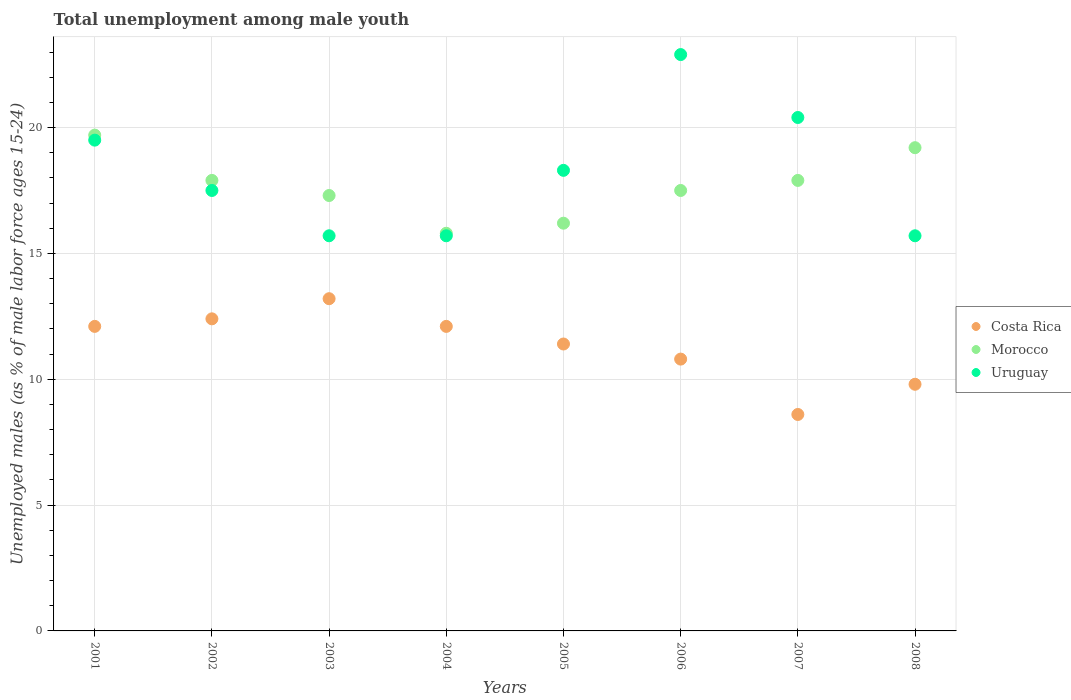How many different coloured dotlines are there?
Your answer should be very brief. 3. Is the number of dotlines equal to the number of legend labels?
Your response must be concise. Yes. What is the percentage of unemployed males in in Costa Rica in 2004?
Ensure brevity in your answer.  12.1. Across all years, what is the maximum percentage of unemployed males in in Costa Rica?
Provide a succinct answer. 13.2. Across all years, what is the minimum percentage of unemployed males in in Costa Rica?
Make the answer very short. 8.6. What is the total percentage of unemployed males in in Uruguay in the graph?
Keep it short and to the point. 145.7. What is the difference between the percentage of unemployed males in in Costa Rica in 2001 and that in 2008?
Give a very brief answer. 2.3. What is the difference between the percentage of unemployed males in in Costa Rica in 2006 and the percentage of unemployed males in in Morocco in 2002?
Keep it short and to the point. -7.1. What is the average percentage of unemployed males in in Morocco per year?
Offer a terse response. 17.69. In the year 2006, what is the difference between the percentage of unemployed males in in Costa Rica and percentage of unemployed males in in Uruguay?
Provide a succinct answer. -12.1. In how many years, is the percentage of unemployed males in in Morocco greater than 16 %?
Ensure brevity in your answer.  7. What is the ratio of the percentage of unemployed males in in Morocco in 2001 to that in 2005?
Provide a short and direct response. 1.22. Is the percentage of unemployed males in in Uruguay in 2007 less than that in 2008?
Your answer should be compact. No. Is the difference between the percentage of unemployed males in in Costa Rica in 2007 and 2008 greater than the difference between the percentage of unemployed males in in Uruguay in 2007 and 2008?
Your response must be concise. No. What is the difference between the highest and the second highest percentage of unemployed males in in Costa Rica?
Offer a very short reply. 0.8. What is the difference between the highest and the lowest percentage of unemployed males in in Uruguay?
Provide a short and direct response. 7.2. In how many years, is the percentage of unemployed males in in Morocco greater than the average percentage of unemployed males in in Morocco taken over all years?
Provide a succinct answer. 4. Is the sum of the percentage of unemployed males in in Morocco in 2002 and 2006 greater than the maximum percentage of unemployed males in in Costa Rica across all years?
Provide a succinct answer. Yes. Does the percentage of unemployed males in in Uruguay monotonically increase over the years?
Offer a very short reply. No. Is the percentage of unemployed males in in Uruguay strictly greater than the percentage of unemployed males in in Morocco over the years?
Offer a very short reply. No. How many dotlines are there?
Offer a very short reply. 3. Does the graph contain any zero values?
Your answer should be very brief. No. How are the legend labels stacked?
Make the answer very short. Vertical. What is the title of the graph?
Your response must be concise. Total unemployment among male youth. Does "Thailand" appear as one of the legend labels in the graph?
Give a very brief answer. No. What is the label or title of the X-axis?
Your response must be concise. Years. What is the label or title of the Y-axis?
Your answer should be compact. Unemployed males (as % of male labor force ages 15-24). What is the Unemployed males (as % of male labor force ages 15-24) of Costa Rica in 2001?
Offer a very short reply. 12.1. What is the Unemployed males (as % of male labor force ages 15-24) in Morocco in 2001?
Make the answer very short. 19.7. What is the Unemployed males (as % of male labor force ages 15-24) of Uruguay in 2001?
Provide a short and direct response. 19.5. What is the Unemployed males (as % of male labor force ages 15-24) in Costa Rica in 2002?
Your answer should be very brief. 12.4. What is the Unemployed males (as % of male labor force ages 15-24) in Morocco in 2002?
Provide a succinct answer. 17.9. What is the Unemployed males (as % of male labor force ages 15-24) in Costa Rica in 2003?
Offer a very short reply. 13.2. What is the Unemployed males (as % of male labor force ages 15-24) of Morocco in 2003?
Your answer should be very brief. 17.3. What is the Unemployed males (as % of male labor force ages 15-24) in Uruguay in 2003?
Provide a succinct answer. 15.7. What is the Unemployed males (as % of male labor force ages 15-24) in Costa Rica in 2004?
Your answer should be compact. 12.1. What is the Unemployed males (as % of male labor force ages 15-24) of Morocco in 2004?
Provide a succinct answer. 15.8. What is the Unemployed males (as % of male labor force ages 15-24) of Uruguay in 2004?
Give a very brief answer. 15.7. What is the Unemployed males (as % of male labor force ages 15-24) in Costa Rica in 2005?
Your response must be concise. 11.4. What is the Unemployed males (as % of male labor force ages 15-24) of Morocco in 2005?
Your response must be concise. 16.2. What is the Unemployed males (as % of male labor force ages 15-24) in Uruguay in 2005?
Ensure brevity in your answer.  18.3. What is the Unemployed males (as % of male labor force ages 15-24) of Costa Rica in 2006?
Provide a short and direct response. 10.8. What is the Unemployed males (as % of male labor force ages 15-24) of Uruguay in 2006?
Ensure brevity in your answer.  22.9. What is the Unemployed males (as % of male labor force ages 15-24) of Costa Rica in 2007?
Offer a very short reply. 8.6. What is the Unemployed males (as % of male labor force ages 15-24) of Morocco in 2007?
Your answer should be very brief. 17.9. What is the Unemployed males (as % of male labor force ages 15-24) of Uruguay in 2007?
Keep it short and to the point. 20.4. What is the Unemployed males (as % of male labor force ages 15-24) in Costa Rica in 2008?
Provide a short and direct response. 9.8. What is the Unemployed males (as % of male labor force ages 15-24) in Morocco in 2008?
Provide a short and direct response. 19.2. What is the Unemployed males (as % of male labor force ages 15-24) of Uruguay in 2008?
Offer a very short reply. 15.7. Across all years, what is the maximum Unemployed males (as % of male labor force ages 15-24) in Costa Rica?
Your answer should be very brief. 13.2. Across all years, what is the maximum Unemployed males (as % of male labor force ages 15-24) in Morocco?
Provide a succinct answer. 19.7. Across all years, what is the maximum Unemployed males (as % of male labor force ages 15-24) in Uruguay?
Provide a short and direct response. 22.9. Across all years, what is the minimum Unemployed males (as % of male labor force ages 15-24) in Costa Rica?
Make the answer very short. 8.6. Across all years, what is the minimum Unemployed males (as % of male labor force ages 15-24) of Morocco?
Give a very brief answer. 15.8. Across all years, what is the minimum Unemployed males (as % of male labor force ages 15-24) in Uruguay?
Ensure brevity in your answer.  15.7. What is the total Unemployed males (as % of male labor force ages 15-24) of Costa Rica in the graph?
Provide a short and direct response. 90.4. What is the total Unemployed males (as % of male labor force ages 15-24) of Morocco in the graph?
Your answer should be compact. 141.5. What is the total Unemployed males (as % of male labor force ages 15-24) of Uruguay in the graph?
Your answer should be very brief. 145.7. What is the difference between the Unemployed males (as % of male labor force ages 15-24) of Costa Rica in 2001 and that in 2002?
Your answer should be very brief. -0.3. What is the difference between the Unemployed males (as % of male labor force ages 15-24) in Morocco in 2001 and that in 2002?
Your answer should be compact. 1.8. What is the difference between the Unemployed males (as % of male labor force ages 15-24) in Costa Rica in 2001 and that in 2003?
Offer a very short reply. -1.1. What is the difference between the Unemployed males (as % of male labor force ages 15-24) in Morocco in 2001 and that in 2003?
Make the answer very short. 2.4. What is the difference between the Unemployed males (as % of male labor force ages 15-24) in Uruguay in 2001 and that in 2003?
Keep it short and to the point. 3.8. What is the difference between the Unemployed males (as % of male labor force ages 15-24) of Costa Rica in 2001 and that in 2006?
Give a very brief answer. 1.3. What is the difference between the Unemployed males (as % of male labor force ages 15-24) in Morocco in 2001 and that in 2006?
Offer a very short reply. 2.2. What is the difference between the Unemployed males (as % of male labor force ages 15-24) in Uruguay in 2001 and that in 2006?
Give a very brief answer. -3.4. What is the difference between the Unemployed males (as % of male labor force ages 15-24) of Uruguay in 2001 and that in 2007?
Provide a succinct answer. -0.9. What is the difference between the Unemployed males (as % of male labor force ages 15-24) in Costa Rica in 2001 and that in 2008?
Offer a very short reply. 2.3. What is the difference between the Unemployed males (as % of male labor force ages 15-24) in Uruguay in 2001 and that in 2008?
Offer a very short reply. 3.8. What is the difference between the Unemployed males (as % of male labor force ages 15-24) of Morocco in 2002 and that in 2003?
Provide a short and direct response. 0.6. What is the difference between the Unemployed males (as % of male labor force ages 15-24) in Costa Rica in 2002 and that in 2004?
Offer a very short reply. 0.3. What is the difference between the Unemployed males (as % of male labor force ages 15-24) of Costa Rica in 2002 and that in 2005?
Keep it short and to the point. 1. What is the difference between the Unemployed males (as % of male labor force ages 15-24) in Costa Rica in 2002 and that in 2006?
Offer a terse response. 1.6. What is the difference between the Unemployed males (as % of male labor force ages 15-24) of Morocco in 2002 and that in 2006?
Provide a succinct answer. 0.4. What is the difference between the Unemployed males (as % of male labor force ages 15-24) in Uruguay in 2002 and that in 2006?
Offer a very short reply. -5.4. What is the difference between the Unemployed males (as % of male labor force ages 15-24) of Morocco in 2002 and that in 2007?
Provide a succinct answer. 0. What is the difference between the Unemployed males (as % of male labor force ages 15-24) in Uruguay in 2002 and that in 2007?
Give a very brief answer. -2.9. What is the difference between the Unemployed males (as % of male labor force ages 15-24) of Costa Rica in 2002 and that in 2008?
Give a very brief answer. 2.6. What is the difference between the Unemployed males (as % of male labor force ages 15-24) of Costa Rica in 2003 and that in 2004?
Your answer should be compact. 1.1. What is the difference between the Unemployed males (as % of male labor force ages 15-24) of Uruguay in 2003 and that in 2004?
Your response must be concise. 0. What is the difference between the Unemployed males (as % of male labor force ages 15-24) of Costa Rica in 2003 and that in 2005?
Keep it short and to the point. 1.8. What is the difference between the Unemployed males (as % of male labor force ages 15-24) of Morocco in 2003 and that in 2005?
Offer a very short reply. 1.1. What is the difference between the Unemployed males (as % of male labor force ages 15-24) in Uruguay in 2003 and that in 2005?
Keep it short and to the point. -2.6. What is the difference between the Unemployed males (as % of male labor force ages 15-24) of Uruguay in 2003 and that in 2006?
Provide a short and direct response. -7.2. What is the difference between the Unemployed males (as % of male labor force ages 15-24) of Costa Rica in 2003 and that in 2007?
Offer a very short reply. 4.6. What is the difference between the Unemployed males (as % of male labor force ages 15-24) of Costa Rica in 2003 and that in 2008?
Make the answer very short. 3.4. What is the difference between the Unemployed males (as % of male labor force ages 15-24) of Morocco in 2003 and that in 2008?
Your answer should be compact. -1.9. What is the difference between the Unemployed males (as % of male labor force ages 15-24) in Costa Rica in 2004 and that in 2005?
Your response must be concise. 0.7. What is the difference between the Unemployed males (as % of male labor force ages 15-24) of Costa Rica in 2004 and that in 2007?
Offer a very short reply. 3.5. What is the difference between the Unemployed males (as % of male labor force ages 15-24) of Uruguay in 2004 and that in 2007?
Keep it short and to the point. -4.7. What is the difference between the Unemployed males (as % of male labor force ages 15-24) in Costa Rica in 2005 and that in 2006?
Offer a terse response. 0.6. What is the difference between the Unemployed males (as % of male labor force ages 15-24) of Morocco in 2005 and that in 2006?
Give a very brief answer. -1.3. What is the difference between the Unemployed males (as % of male labor force ages 15-24) of Costa Rica in 2005 and that in 2007?
Your answer should be compact. 2.8. What is the difference between the Unemployed males (as % of male labor force ages 15-24) of Morocco in 2005 and that in 2007?
Offer a very short reply. -1.7. What is the difference between the Unemployed males (as % of male labor force ages 15-24) of Morocco in 2005 and that in 2008?
Provide a short and direct response. -3. What is the difference between the Unemployed males (as % of male labor force ages 15-24) of Morocco in 2006 and that in 2007?
Your answer should be compact. -0.4. What is the difference between the Unemployed males (as % of male labor force ages 15-24) of Costa Rica in 2007 and that in 2008?
Keep it short and to the point. -1.2. What is the difference between the Unemployed males (as % of male labor force ages 15-24) in Morocco in 2007 and that in 2008?
Offer a terse response. -1.3. What is the difference between the Unemployed males (as % of male labor force ages 15-24) of Uruguay in 2007 and that in 2008?
Offer a very short reply. 4.7. What is the difference between the Unemployed males (as % of male labor force ages 15-24) in Costa Rica in 2001 and the Unemployed males (as % of male labor force ages 15-24) in Uruguay in 2003?
Your response must be concise. -3.6. What is the difference between the Unemployed males (as % of male labor force ages 15-24) in Costa Rica in 2001 and the Unemployed males (as % of male labor force ages 15-24) in Uruguay in 2004?
Your response must be concise. -3.6. What is the difference between the Unemployed males (as % of male labor force ages 15-24) of Costa Rica in 2001 and the Unemployed males (as % of male labor force ages 15-24) of Morocco in 2005?
Your answer should be very brief. -4.1. What is the difference between the Unemployed males (as % of male labor force ages 15-24) of Costa Rica in 2001 and the Unemployed males (as % of male labor force ages 15-24) of Uruguay in 2005?
Offer a terse response. -6.2. What is the difference between the Unemployed males (as % of male labor force ages 15-24) in Costa Rica in 2001 and the Unemployed males (as % of male labor force ages 15-24) in Uruguay in 2006?
Give a very brief answer. -10.8. What is the difference between the Unemployed males (as % of male labor force ages 15-24) in Morocco in 2001 and the Unemployed males (as % of male labor force ages 15-24) in Uruguay in 2006?
Offer a terse response. -3.2. What is the difference between the Unemployed males (as % of male labor force ages 15-24) in Costa Rica in 2001 and the Unemployed males (as % of male labor force ages 15-24) in Uruguay in 2007?
Your response must be concise. -8.3. What is the difference between the Unemployed males (as % of male labor force ages 15-24) in Morocco in 2001 and the Unemployed males (as % of male labor force ages 15-24) in Uruguay in 2008?
Provide a succinct answer. 4. What is the difference between the Unemployed males (as % of male labor force ages 15-24) of Costa Rica in 2002 and the Unemployed males (as % of male labor force ages 15-24) of Morocco in 2003?
Your response must be concise. -4.9. What is the difference between the Unemployed males (as % of male labor force ages 15-24) of Morocco in 2002 and the Unemployed males (as % of male labor force ages 15-24) of Uruguay in 2003?
Your response must be concise. 2.2. What is the difference between the Unemployed males (as % of male labor force ages 15-24) in Costa Rica in 2002 and the Unemployed males (as % of male labor force ages 15-24) in Morocco in 2004?
Provide a short and direct response. -3.4. What is the difference between the Unemployed males (as % of male labor force ages 15-24) in Costa Rica in 2002 and the Unemployed males (as % of male labor force ages 15-24) in Uruguay in 2004?
Give a very brief answer. -3.3. What is the difference between the Unemployed males (as % of male labor force ages 15-24) of Morocco in 2002 and the Unemployed males (as % of male labor force ages 15-24) of Uruguay in 2004?
Your response must be concise. 2.2. What is the difference between the Unemployed males (as % of male labor force ages 15-24) of Costa Rica in 2002 and the Unemployed males (as % of male labor force ages 15-24) of Morocco in 2005?
Your response must be concise. -3.8. What is the difference between the Unemployed males (as % of male labor force ages 15-24) of Morocco in 2002 and the Unemployed males (as % of male labor force ages 15-24) of Uruguay in 2005?
Provide a succinct answer. -0.4. What is the difference between the Unemployed males (as % of male labor force ages 15-24) in Costa Rica in 2002 and the Unemployed males (as % of male labor force ages 15-24) in Morocco in 2006?
Your answer should be compact. -5.1. What is the difference between the Unemployed males (as % of male labor force ages 15-24) in Morocco in 2002 and the Unemployed males (as % of male labor force ages 15-24) in Uruguay in 2006?
Your response must be concise. -5. What is the difference between the Unemployed males (as % of male labor force ages 15-24) of Costa Rica in 2002 and the Unemployed males (as % of male labor force ages 15-24) of Morocco in 2007?
Provide a succinct answer. -5.5. What is the difference between the Unemployed males (as % of male labor force ages 15-24) of Costa Rica in 2002 and the Unemployed males (as % of male labor force ages 15-24) of Uruguay in 2007?
Offer a terse response. -8. What is the difference between the Unemployed males (as % of male labor force ages 15-24) of Morocco in 2002 and the Unemployed males (as % of male labor force ages 15-24) of Uruguay in 2007?
Offer a terse response. -2.5. What is the difference between the Unemployed males (as % of male labor force ages 15-24) in Costa Rica in 2003 and the Unemployed males (as % of male labor force ages 15-24) in Morocco in 2004?
Offer a terse response. -2.6. What is the difference between the Unemployed males (as % of male labor force ages 15-24) of Morocco in 2003 and the Unemployed males (as % of male labor force ages 15-24) of Uruguay in 2004?
Keep it short and to the point. 1.6. What is the difference between the Unemployed males (as % of male labor force ages 15-24) in Costa Rica in 2003 and the Unemployed males (as % of male labor force ages 15-24) in Morocco in 2005?
Ensure brevity in your answer.  -3. What is the difference between the Unemployed males (as % of male labor force ages 15-24) of Costa Rica in 2003 and the Unemployed males (as % of male labor force ages 15-24) of Uruguay in 2005?
Ensure brevity in your answer.  -5.1. What is the difference between the Unemployed males (as % of male labor force ages 15-24) of Morocco in 2003 and the Unemployed males (as % of male labor force ages 15-24) of Uruguay in 2005?
Offer a very short reply. -1. What is the difference between the Unemployed males (as % of male labor force ages 15-24) of Costa Rica in 2003 and the Unemployed males (as % of male labor force ages 15-24) of Uruguay in 2006?
Provide a short and direct response. -9.7. What is the difference between the Unemployed males (as % of male labor force ages 15-24) of Morocco in 2003 and the Unemployed males (as % of male labor force ages 15-24) of Uruguay in 2006?
Make the answer very short. -5.6. What is the difference between the Unemployed males (as % of male labor force ages 15-24) of Costa Rica in 2003 and the Unemployed males (as % of male labor force ages 15-24) of Morocco in 2008?
Your answer should be compact. -6. What is the difference between the Unemployed males (as % of male labor force ages 15-24) in Costa Rica in 2004 and the Unemployed males (as % of male labor force ages 15-24) in Uruguay in 2006?
Offer a very short reply. -10.8. What is the difference between the Unemployed males (as % of male labor force ages 15-24) in Morocco in 2004 and the Unemployed males (as % of male labor force ages 15-24) in Uruguay in 2006?
Ensure brevity in your answer.  -7.1. What is the difference between the Unemployed males (as % of male labor force ages 15-24) of Costa Rica in 2004 and the Unemployed males (as % of male labor force ages 15-24) of Uruguay in 2007?
Give a very brief answer. -8.3. What is the difference between the Unemployed males (as % of male labor force ages 15-24) in Costa Rica in 2004 and the Unemployed males (as % of male labor force ages 15-24) in Uruguay in 2008?
Provide a short and direct response. -3.6. What is the difference between the Unemployed males (as % of male labor force ages 15-24) in Morocco in 2005 and the Unemployed males (as % of male labor force ages 15-24) in Uruguay in 2006?
Provide a succinct answer. -6.7. What is the difference between the Unemployed males (as % of male labor force ages 15-24) in Morocco in 2005 and the Unemployed males (as % of male labor force ages 15-24) in Uruguay in 2007?
Provide a succinct answer. -4.2. What is the difference between the Unemployed males (as % of male labor force ages 15-24) in Costa Rica in 2005 and the Unemployed males (as % of male labor force ages 15-24) in Morocco in 2008?
Your answer should be very brief. -7.8. What is the difference between the Unemployed males (as % of male labor force ages 15-24) in Costa Rica in 2006 and the Unemployed males (as % of male labor force ages 15-24) in Morocco in 2007?
Provide a short and direct response. -7.1. What is the average Unemployed males (as % of male labor force ages 15-24) in Costa Rica per year?
Make the answer very short. 11.3. What is the average Unemployed males (as % of male labor force ages 15-24) in Morocco per year?
Keep it short and to the point. 17.69. What is the average Unemployed males (as % of male labor force ages 15-24) of Uruguay per year?
Make the answer very short. 18.21. In the year 2001, what is the difference between the Unemployed males (as % of male labor force ages 15-24) of Costa Rica and Unemployed males (as % of male labor force ages 15-24) of Morocco?
Provide a short and direct response. -7.6. In the year 2001, what is the difference between the Unemployed males (as % of male labor force ages 15-24) in Costa Rica and Unemployed males (as % of male labor force ages 15-24) in Uruguay?
Provide a short and direct response. -7.4. In the year 2002, what is the difference between the Unemployed males (as % of male labor force ages 15-24) of Costa Rica and Unemployed males (as % of male labor force ages 15-24) of Morocco?
Your answer should be very brief. -5.5. In the year 2003, what is the difference between the Unemployed males (as % of male labor force ages 15-24) in Costa Rica and Unemployed males (as % of male labor force ages 15-24) in Morocco?
Give a very brief answer. -4.1. In the year 2003, what is the difference between the Unemployed males (as % of male labor force ages 15-24) in Costa Rica and Unemployed males (as % of male labor force ages 15-24) in Uruguay?
Ensure brevity in your answer.  -2.5. In the year 2004, what is the difference between the Unemployed males (as % of male labor force ages 15-24) of Costa Rica and Unemployed males (as % of male labor force ages 15-24) of Uruguay?
Your answer should be very brief. -3.6. In the year 2004, what is the difference between the Unemployed males (as % of male labor force ages 15-24) of Morocco and Unemployed males (as % of male labor force ages 15-24) of Uruguay?
Keep it short and to the point. 0.1. In the year 2005, what is the difference between the Unemployed males (as % of male labor force ages 15-24) of Costa Rica and Unemployed males (as % of male labor force ages 15-24) of Uruguay?
Give a very brief answer. -6.9. In the year 2005, what is the difference between the Unemployed males (as % of male labor force ages 15-24) of Morocco and Unemployed males (as % of male labor force ages 15-24) of Uruguay?
Offer a very short reply. -2.1. In the year 2006, what is the difference between the Unemployed males (as % of male labor force ages 15-24) in Costa Rica and Unemployed males (as % of male labor force ages 15-24) in Morocco?
Provide a succinct answer. -6.7. In the year 2006, what is the difference between the Unemployed males (as % of male labor force ages 15-24) of Costa Rica and Unemployed males (as % of male labor force ages 15-24) of Uruguay?
Your answer should be compact. -12.1. In the year 2008, what is the difference between the Unemployed males (as % of male labor force ages 15-24) of Costa Rica and Unemployed males (as % of male labor force ages 15-24) of Uruguay?
Provide a short and direct response. -5.9. What is the ratio of the Unemployed males (as % of male labor force ages 15-24) of Costa Rica in 2001 to that in 2002?
Offer a very short reply. 0.98. What is the ratio of the Unemployed males (as % of male labor force ages 15-24) in Morocco in 2001 to that in 2002?
Give a very brief answer. 1.1. What is the ratio of the Unemployed males (as % of male labor force ages 15-24) of Uruguay in 2001 to that in 2002?
Keep it short and to the point. 1.11. What is the ratio of the Unemployed males (as % of male labor force ages 15-24) in Morocco in 2001 to that in 2003?
Your response must be concise. 1.14. What is the ratio of the Unemployed males (as % of male labor force ages 15-24) in Uruguay in 2001 to that in 2003?
Provide a succinct answer. 1.24. What is the ratio of the Unemployed males (as % of male labor force ages 15-24) in Morocco in 2001 to that in 2004?
Keep it short and to the point. 1.25. What is the ratio of the Unemployed males (as % of male labor force ages 15-24) of Uruguay in 2001 to that in 2004?
Offer a terse response. 1.24. What is the ratio of the Unemployed males (as % of male labor force ages 15-24) of Costa Rica in 2001 to that in 2005?
Offer a very short reply. 1.06. What is the ratio of the Unemployed males (as % of male labor force ages 15-24) in Morocco in 2001 to that in 2005?
Make the answer very short. 1.22. What is the ratio of the Unemployed males (as % of male labor force ages 15-24) in Uruguay in 2001 to that in 2005?
Ensure brevity in your answer.  1.07. What is the ratio of the Unemployed males (as % of male labor force ages 15-24) in Costa Rica in 2001 to that in 2006?
Offer a terse response. 1.12. What is the ratio of the Unemployed males (as % of male labor force ages 15-24) in Morocco in 2001 to that in 2006?
Your answer should be very brief. 1.13. What is the ratio of the Unemployed males (as % of male labor force ages 15-24) of Uruguay in 2001 to that in 2006?
Offer a very short reply. 0.85. What is the ratio of the Unemployed males (as % of male labor force ages 15-24) of Costa Rica in 2001 to that in 2007?
Make the answer very short. 1.41. What is the ratio of the Unemployed males (as % of male labor force ages 15-24) of Morocco in 2001 to that in 2007?
Provide a succinct answer. 1.1. What is the ratio of the Unemployed males (as % of male labor force ages 15-24) in Uruguay in 2001 to that in 2007?
Offer a terse response. 0.96. What is the ratio of the Unemployed males (as % of male labor force ages 15-24) in Costa Rica in 2001 to that in 2008?
Make the answer very short. 1.23. What is the ratio of the Unemployed males (as % of male labor force ages 15-24) of Uruguay in 2001 to that in 2008?
Ensure brevity in your answer.  1.24. What is the ratio of the Unemployed males (as % of male labor force ages 15-24) of Costa Rica in 2002 to that in 2003?
Your answer should be very brief. 0.94. What is the ratio of the Unemployed males (as % of male labor force ages 15-24) of Morocco in 2002 to that in 2003?
Make the answer very short. 1.03. What is the ratio of the Unemployed males (as % of male labor force ages 15-24) of Uruguay in 2002 to that in 2003?
Provide a short and direct response. 1.11. What is the ratio of the Unemployed males (as % of male labor force ages 15-24) in Costa Rica in 2002 to that in 2004?
Make the answer very short. 1.02. What is the ratio of the Unemployed males (as % of male labor force ages 15-24) of Morocco in 2002 to that in 2004?
Keep it short and to the point. 1.13. What is the ratio of the Unemployed males (as % of male labor force ages 15-24) of Uruguay in 2002 to that in 2004?
Your answer should be very brief. 1.11. What is the ratio of the Unemployed males (as % of male labor force ages 15-24) of Costa Rica in 2002 to that in 2005?
Give a very brief answer. 1.09. What is the ratio of the Unemployed males (as % of male labor force ages 15-24) of Morocco in 2002 to that in 2005?
Provide a succinct answer. 1.1. What is the ratio of the Unemployed males (as % of male labor force ages 15-24) of Uruguay in 2002 to that in 2005?
Offer a very short reply. 0.96. What is the ratio of the Unemployed males (as % of male labor force ages 15-24) of Costa Rica in 2002 to that in 2006?
Your answer should be very brief. 1.15. What is the ratio of the Unemployed males (as % of male labor force ages 15-24) of Morocco in 2002 to that in 2006?
Offer a very short reply. 1.02. What is the ratio of the Unemployed males (as % of male labor force ages 15-24) in Uruguay in 2002 to that in 2006?
Your answer should be very brief. 0.76. What is the ratio of the Unemployed males (as % of male labor force ages 15-24) of Costa Rica in 2002 to that in 2007?
Provide a short and direct response. 1.44. What is the ratio of the Unemployed males (as % of male labor force ages 15-24) of Uruguay in 2002 to that in 2007?
Give a very brief answer. 0.86. What is the ratio of the Unemployed males (as % of male labor force ages 15-24) of Costa Rica in 2002 to that in 2008?
Provide a short and direct response. 1.27. What is the ratio of the Unemployed males (as % of male labor force ages 15-24) in Morocco in 2002 to that in 2008?
Keep it short and to the point. 0.93. What is the ratio of the Unemployed males (as % of male labor force ages 15-24) in Uruguay in 2002 to that in 2008?
Keep it short and to the point. 1.11. What is the ratio of the Unemployed males (as % of male labor force ages 15-24) in Morocco in 2003 to that in 2004?
Make the answer very short. 1.09. What is the ratio of the Unemployed males (as % of male labor force ages 15-24) of Uruguay in 2003 to that in 2004?
Your answer should be very brief. 1. What is the ratio of the Unemployed males (as % of male labor force ages 15-24) in Costa Rica in 2003 to that in 2005?
Your answer should be very brief. 1.16. What is the ratio of the Unemployed males (as % of male labor force ages 15-24) of Morocco in 2003 to that in 2005?
Provide a short and direct response. 1.07. What is the ratio of the Unemployed males (as % of male labor force ages 15-24) in Uruguay in 2003 to that in 2005?
Give a very brief answer. 0.86. What is the ratio of the Unemployed males (as % of male labor force ages 15-24) of Costa Rica in 2003 to that in 2006?
Give a very brief answer. 1.22. What is the ratio of the Unemployed males (as % of male labor force ages 15-24) in Morocco in 2003 to that in 2006?
Ensure brevity in your answer.  0.99. What is the ratio of the Unemployed males (as % of male labor force ages 15-24) of Uruguay in 2003 to that in 2006?
Make the answer very short. 0.69. What is the ratio of the Unemployed males (as % of male labor force ages 15-24) in Costa Rica in 2003 to that in 2007?
Ensure brevity in your answer.  1.53. What is the ratio of the Unemployed males (as % of male labor force ages 15-24) in Morocco in 2003 to that in 2007?
Provide a succinct answer. 0.97. What is the ratio of the Unemployed males (as % of male labor force ages 15-24) of Uruguay in 2003 to that in 2007?
Your answer should be very brief. 0.77. What is the ratio of the Unemployed males (as % of male labor force ages 15-24) of Costa Rica in 2003 to that in 2008?
Make the answer very short. 1.35. What is the ratio of the Unemployed males (as % of male labor force ages 15-24) in Morocco in 2003 to that in 2008?
Your response must be concise. 0.9. What is the ratio of the Unemployed males (as % of male labor force ages 15-24) in Costa Rica in 2004 to that in 2005?
Offer a terse response. 1.06. What is the ratio of the Unemployed males (as % of male labor force ages 15-24) in Morocco in 2004 to that in 2005?
Ensure brevity in your answer.  0.98. What is the ratio of the Unemployed males (as % of male labor force ages 15-24) of Uruguay in 2004 to that in 2005?
Your answer should be very brief. 0.86. What is the ratio of the Unemployed males (as % of male labor force ages 15-24) of Costa Rica in 2004 to that in 2006?
Make the answer very short. 1.12. What is the ratio of the Unemployed males (as % of male labor force ages 15-24) in Morocco in 2004 to that in 2006?
Keep it short and to the point. 0.9. What is the ratio of the Unemployed males (as % of male labor force ages 15-24) of Uruguay in 2004 to that in 2006?
Give a very brief answer. 0.69. What is the ratio of the Unemployed males (as % of male labor force ages 15-24) in Costa Rica in 2004 to that in 2007?
Provide a succinct answer. 1.41. What is the ratio of the Unemployed males (as % of male labor force ages 15-24) in Morocco in 2004 to that in 2007?
Provide a succinct answer. 0.88. What is the ratio of the Unemployed males (as % of male labor force ages 15-24) in Uruguay in 2004 to that in 2007?
Offer a very short reply. 0.77. What is the ratio of the Unemployed males (as % of male labor force ages 15-24) in Costa Rica in 2004 to that in 2008?
Ensure brevity in your answer.  1.23. What is the ratio of the Unemployed males (as % of male labor force ages 15-24) of Morocco in 2004 to that in 2008?
Offer a terse response. 0.82. What is the ratio of the Unemployed males (as % of male labor force ages 15-24) of Costa Rica in 2005 to that in 2006?
Your answer should be very brief. 1.06. What is the ratio of the Unemployed males (as % of male labor force ages 15-24) in Morocco in 2005 to that in 2006?
Offer a very short reply. 0.93. What is the ratio of the Unemployed males (as % of male labor force ages 15-24) of Uruguay in 2005 to that in 2006?
Make the answer very short. 0.8. What is the ratio of the Unemployed males (as % of male labor force ages 15-24) of Costa Rica in 2005 to that in 2007?
Provide a short and direct response. 1.33. What is the ratio of the Unemployed males (as % of male labor force ages 15-24) in Morocco in 2005 to that in 2007?
Provide a succinct answer. 0.91. What is the ratio of the Unemployed males (as % of male labor force ages 15-24) of Uruguay in 2005 to that in 2007?
Ensure brevity in your answer.  0.9. What is the ratio of the Unemployed males (as % of male labor force ages 15-24) of Costa Rica in 2005 to that in 2008?
Provide a succinct answer. 1.16. What is the ratio of the Unemployed males (as % of male labor force ages 15-24) in Morocco in 2005 to that in 2008?
Offer a terse response. 0.84. What is the ratio of the Unemployed males (as % of male labor force ages 15-24) of Uruguay in 2005 to that in 2008?
Give a very brief answer. 1.17. What is the ratio of the Unemployed males (as % of male labor force ages 15-24) of Costa Rica in 2006 to that in 2007?
Offer a terse response. 1.26. What is the ratio of the Unemployed males (as % of male labor force ages 15-24) in Morocco in 2006 to that in 2007?
Provide a short and direct response. 0.98. What is the ratio of the Unemployed males (as % of male labor force ages 15-24) of Uruguay in 2006 to that in 2007?
Your answer should be compact. 1.12. What is the ratio of the Unemployed males (as % of male labor force ages 15-24) in Costa Rica in 2006 to that in 2008?
Offer a very short reply. 1.1. What is the ratio of the Unemployed males (as % of male labor force ages 15-24) of Morocco in 2006 to that in 2008?
Ensure brevity in your answer.  0.91. What is the ratio of the Unemployed males (as % of male labor force ages 15-24) of Uruguay in 2006 to that in 2008?
Keep it short and to the point. 1.46. What is the ratio of the Unemployed males (as % of male labor force ages 15-24) in Costa Rica in 2007 to that in 2008?
Offer a terse response. 0.88. What is the ratio of the Unemployed males (as % of male labor force ages 15-24) of Morocco in 2007 to that in 2008?
Offer a very short reply. 0.93. What is the ratio of the Unemployed males (as % of male labor force ages 15-24) in Uruguay in 2007 to that in 2008?
Offer a terse response. 1.3. What is the difference between the highest and the second highest Unemployed males (as % of male labor force ages 15-24) of Uruguay?
Give a very brief answer. 2.5. What is the difference between the highest and the lowest Unemployed males (as % of male labor force ages 15-24) of Morocco?
Offer a terse response. 3.9. 